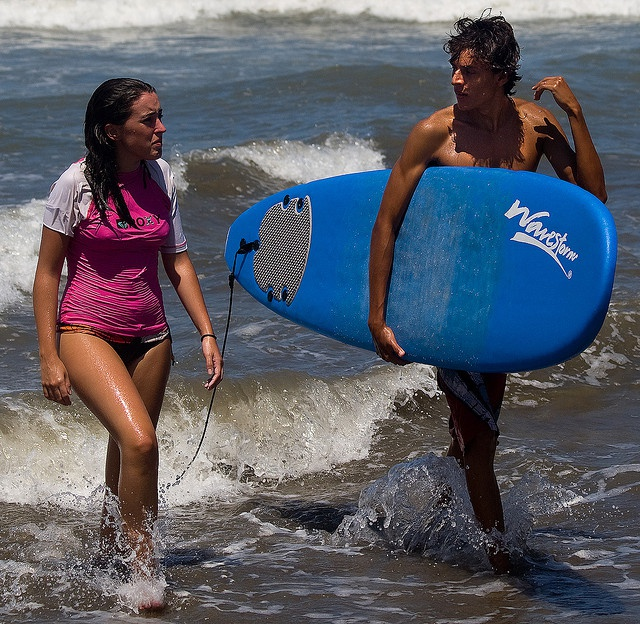Describe the objects in this image and their specific colors. I can see surfboard in lightgray, blue, navy, and black tones, people in lightgray, black, maroon, brown, and gray tones, and people in lightgray, black, maroon, and brown tones in this image. 